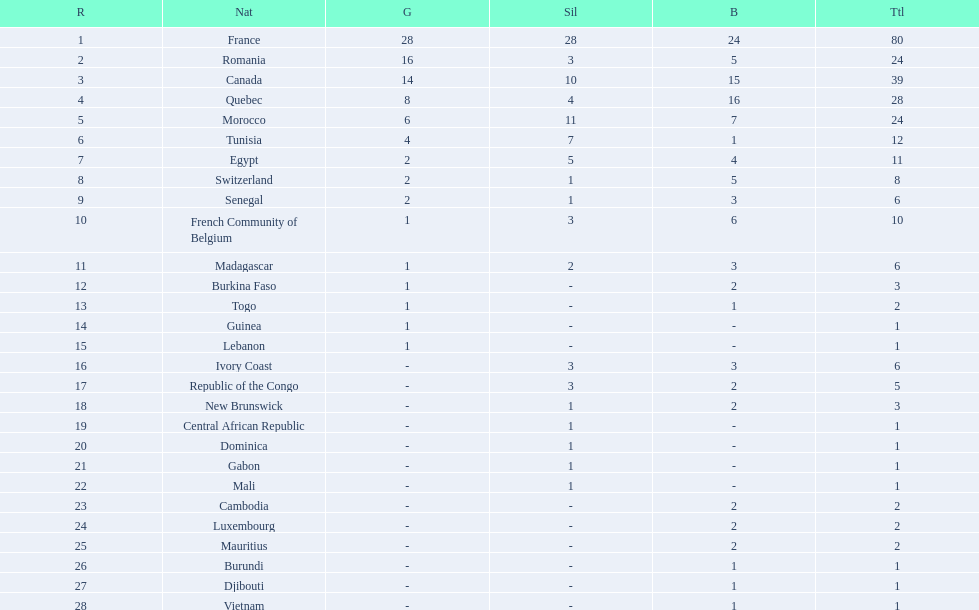What was the total medal count of switzerland? 8. 